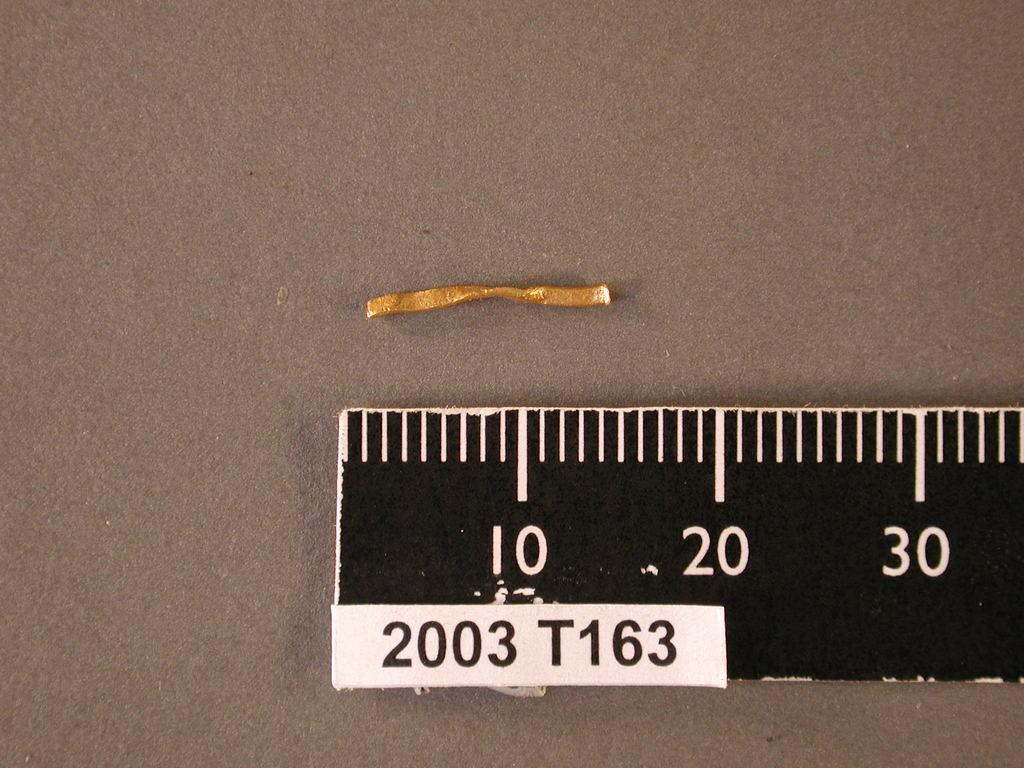What is located on the right side of the image? There is a ruler scale on the right side of the image. What is the color of the surface on which the ruler scale is placed? The ruler scale is on a gray colored surface. What else can be seen on the surface? There is an object on the surface. What type of flag is being waved by the object on the surface? There is no flag present in the image, and the object on the surface is not waving anything. 